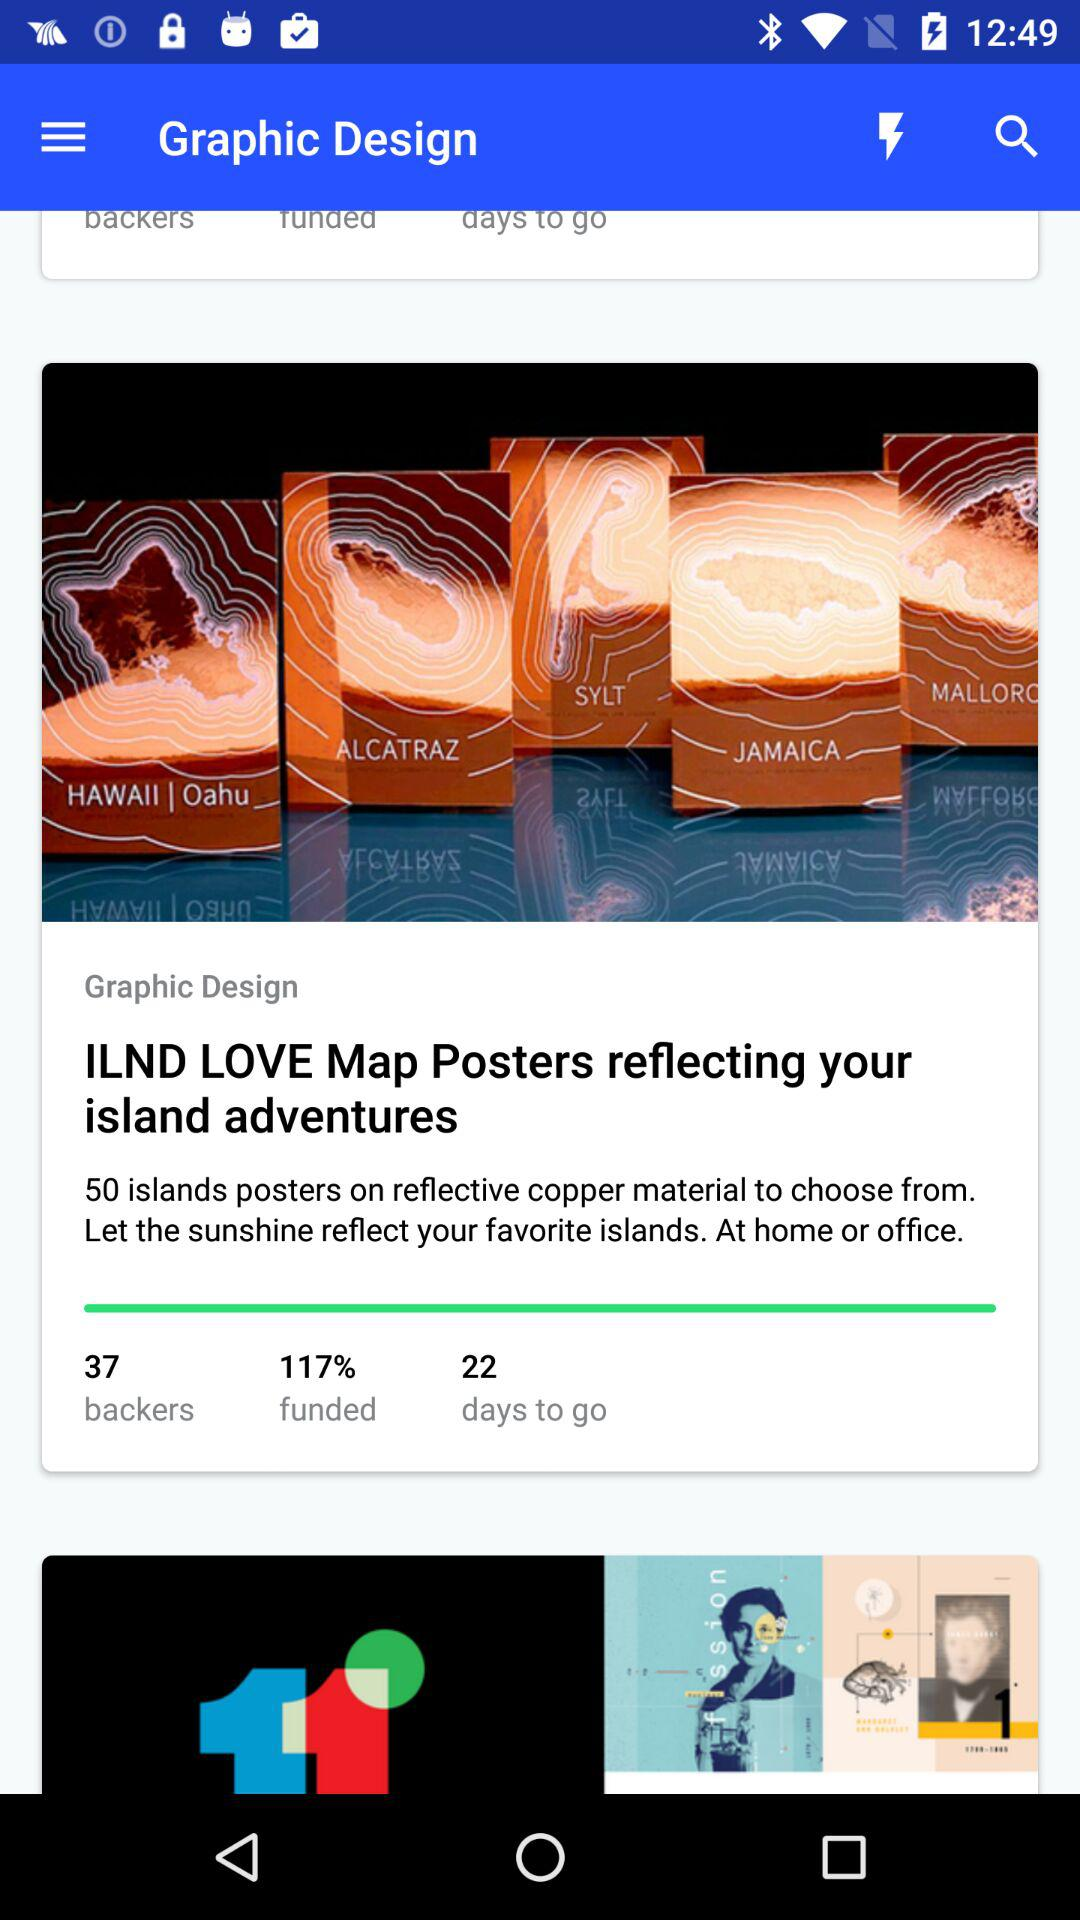How many days to go? There are 22 days to go. 